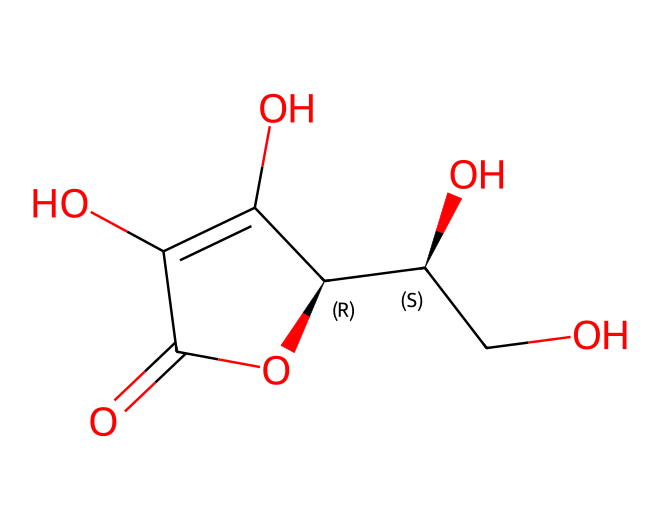What is the molecular formula of vitamin C as represented in the SMILES? To determine the molecular formula, we need to decode the SMILES representation, which includes the atoms present. The structure contains 6 carbon atoms (C), 8 hydrogen atoms (H), and 6 oxygen atoms (O), leading to the empirical formula C6H8O6.
Answer: C6H8O6 How many oxygen atoms are in the structure of vitamin C? By analyzing the SMILES, we can see the presence of multiple 'O' characters representing oxygen atoms in the structure. Counting the 'O's gives us a total of 6.
Answer: 6 What type of functional groups are present in vitamin C? The SMILES indicates the presence of hydroxyl (-OH) groups as indicated by the 'O' atoms directly connected to carbon atoms. Additionally, the presence of a lactone ring can be inferred from the cyclic structure. This combination of groups is characteristic of alcohols and ethers.
Answer: hydroxyl and lactone How does the ring structure of vitamin C contribute to its antioxidant properties? The ring structure in vitamin C allows for the stabilization of the electron distribution, making it an effective electron donor. This is crucial for its action as an antioxidant, as it can donate electrons to free radicals, neutralizing their reactivity. The cyclic arrangement also facilitates intramolecular hydrogen bonding, contributing to its stability.
Answer: stabilization What is the role of the one double bond in the vitamin C structure? The presence of a double bond in the structure allows for greater reactivity in the molecule. It can influence the molecule's electronic properties and is essential for the antioxidant capacity because it leads to electron delocalization, helping in the transfer of electrons to free radicals.
Answer: reactivity 